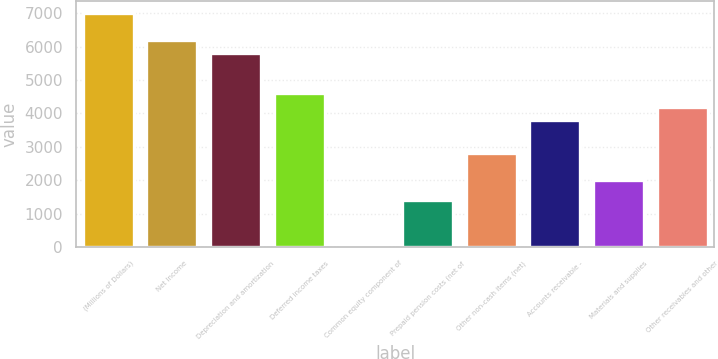Convert chart. <chart><loc_0><loc_0><loc_500><loc_500><bar_chart><fcel>(Millions of Dollars)<fcel>Net Income<fcel>Depreciation and amortization<fcel>Deferred income taxes<fcel>Common equity component of<fcel>Prepaid pension costs (net of<fcel>Other non-cash items (net)<fcel>Accounts receivable -<fcel>Materials and supplies<fcel>Other receivables and other<nl><fcel>7006<fcel>6206<fcel>5806<fcel>4606<fcel>6<fcel>1406<fcel>2806<fcel>3806<fcel>2006<fcel>4206<nl></chart> 